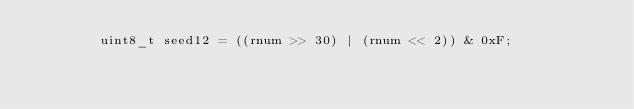<code> <loc_0><loc_0><loc_500><loc_500><_C++_>        uint8_t seed12 = ((rnum >> 30) | (rnum << 2)) & 0xF;
</code> 